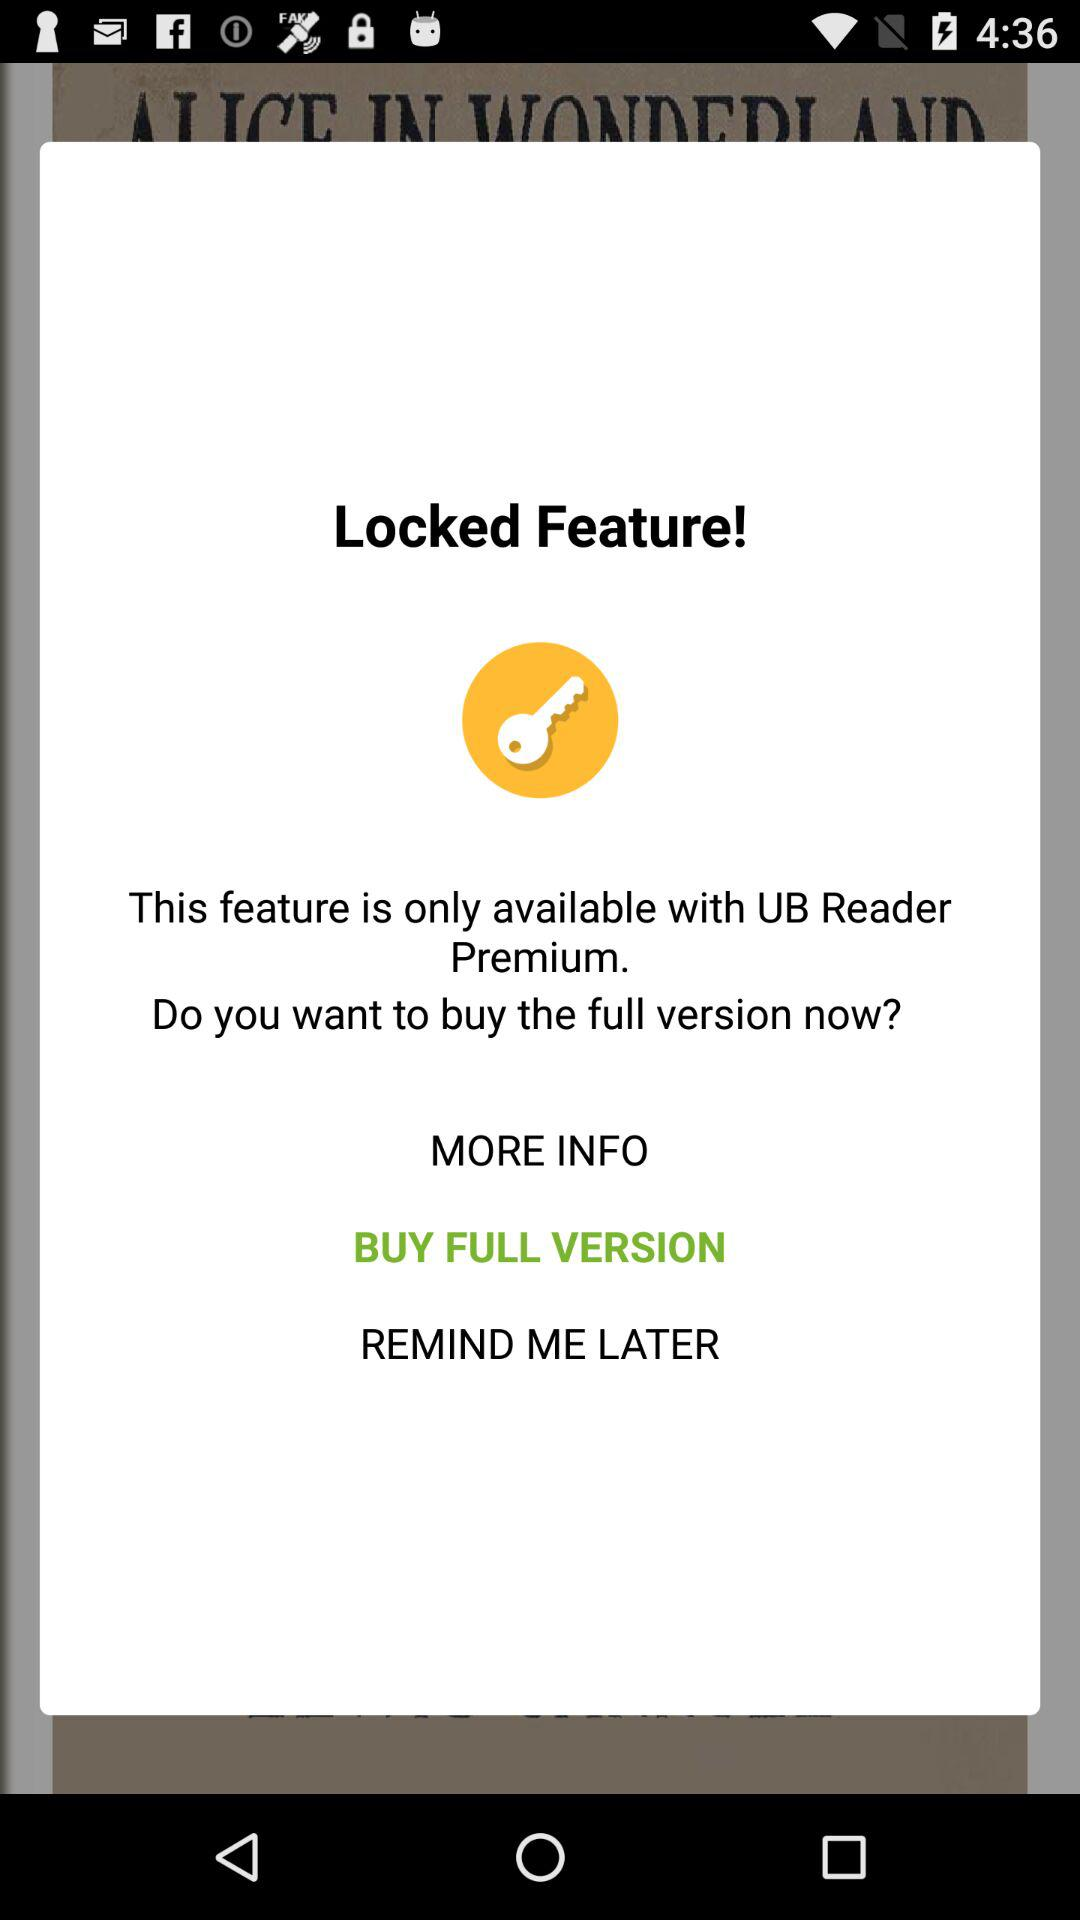How much is the full version?
When the provided information is insufficient, respond with <no answer>. <no answer> 